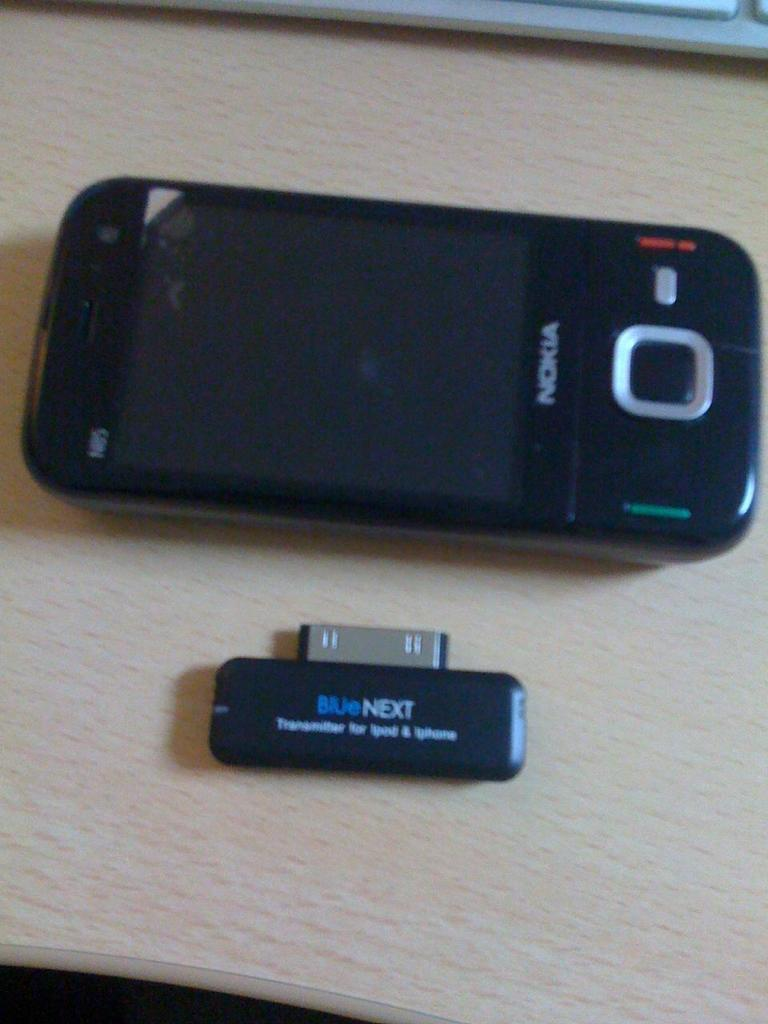<image>
Provide a brief description of the given image. Black Nokia phone next to a USB that says Blue Next. 